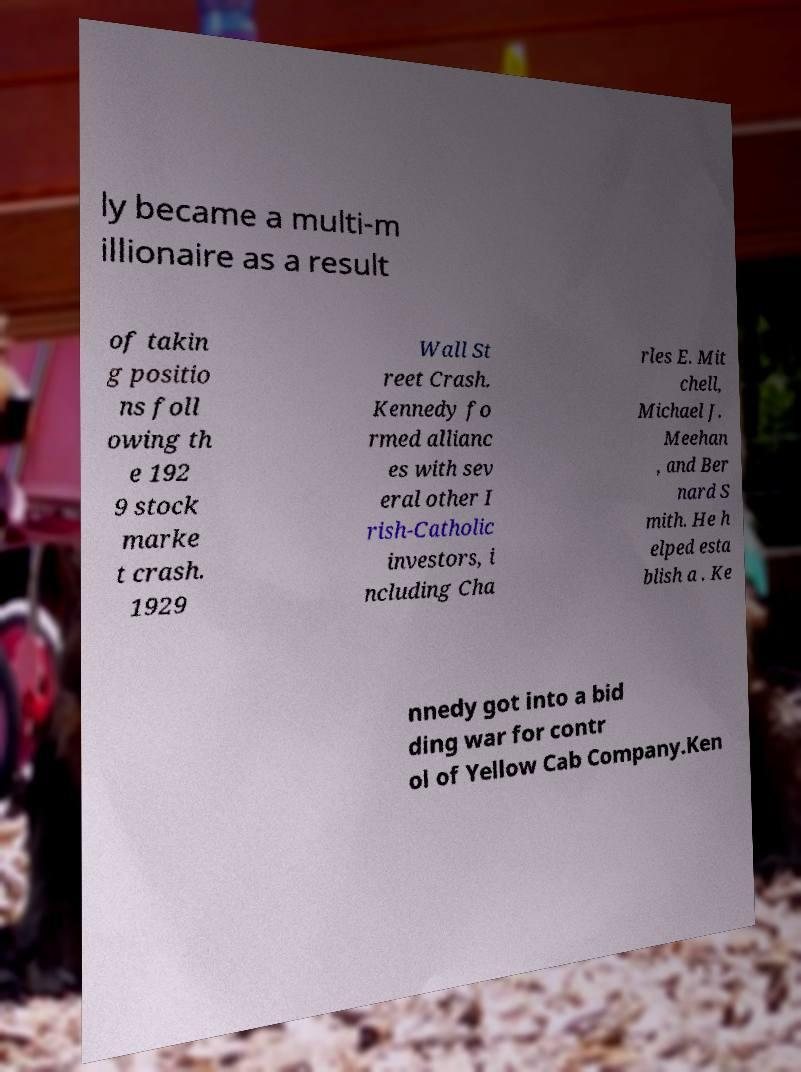Could you assist in decoding the text presented in this image and type it out clearly? ly became a multi-m illionaire as a result of takin g positio ns foll owing th e 192 9 stock marke t crash. 1929 Wall St reet Crash. Kennedy fo rmed allianc es with sev eral other I rish-Catholic investors, i ncluding Cha rles E. Mit chell, Michael J. Meehan , and Ber nard S mith. He h elped esta blish a . Ke nnedy got into a bid ding war for contr ol of Yellow Cab Company.Ken 